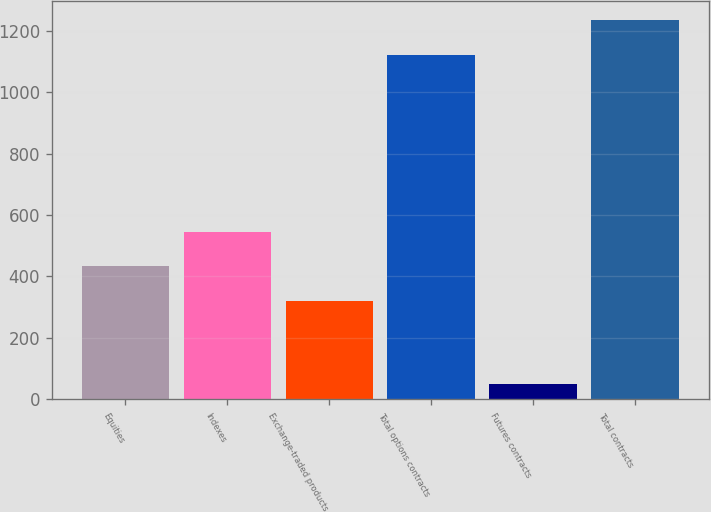Convert chart to OTSL. <chart><loc_0><loc_0><loc_500><loc_500><bar_chart><fcel>Equities<fcel>Indexes<fcel>Exchange-traded products<fcel>Total options contracts<fcel>Futures contracts<fcel>Total contracts<nl><fcel>433.23<fcel>545.46<fcel>321<fcel>1122.3<fcel>51.7<fcel>1234.53<nl></chart> 